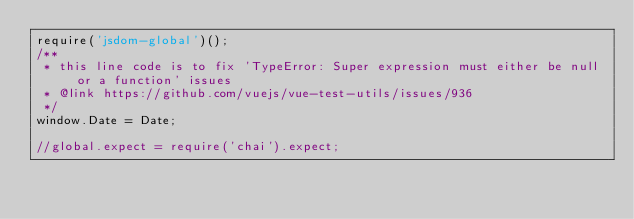Convert code to text. <code><loc_0><loc_0><loc_500><loc_500><_JavaScript_>require('jsdom-global')();
/**
 * this line code is to fix 'TypeError: Super expression must either be null or a function' issues
 * @link https://github.com/vuejs/vue-test-utils/issues/936
 */
window.Date = Date;

//global.expect = require('chai').expect;</code> 